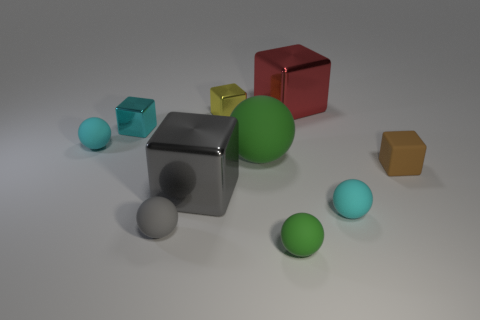Subtract all yellow cubes. How many cubes are left? 4 Subtract all brown rubber blocks. How many blocks are left? 4 Subtract 1 cubes. How many cubes are left? 4 Subtract all purple cubes. How many purple spheres are left? 0 Add 6 cyan shiny things. How many cyan shiny things are left? 7 Add 8 small brown cubes. How many small brown cubes exist? 9 Subtract 0 green cubes. How many objects are left? 10 Subtract all red spheres. Subtract all red blocks. How many spheres are left? 5 Subtract all metallic cubes. Subtract all small brown blocks. How many objects are left? 5 